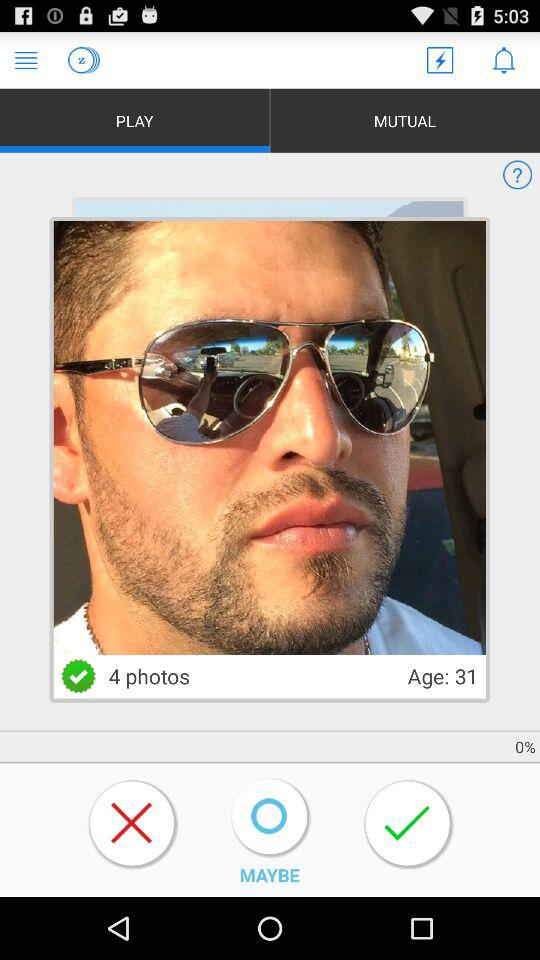Which tab has been selected? The selected tab is "PLAY". 